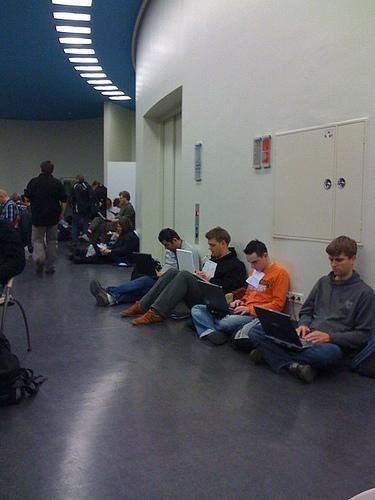How many men are wearing orange shoes?
Give a very brief answer. 1. How many people are sitting on the floor on the right?
Give a very brief answer. 4. How many people are there?
Give a very brief answer. 5. 